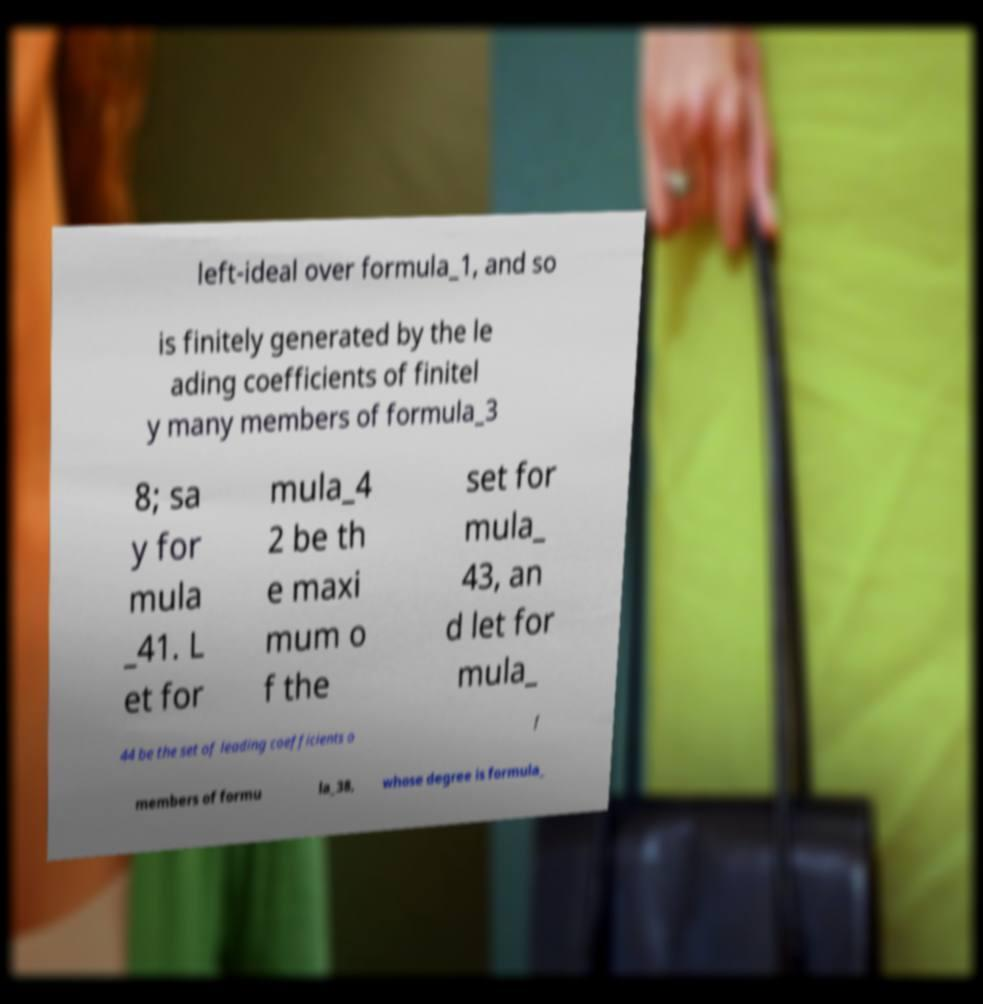What messages or text are displayed in this image? I need them in a readable, typed format. left-ideal over formula_1, and so is finitely generated by the le ading coefficients of finitel y many members of formula_3 8; sa y for mula _41. L et for mula_4 2 be th e maxi mum o f the set for mula_ 43, an d let for mula_ 44 be the set of leading coefficients o f members of formu la_38, whose degree is formula_ 